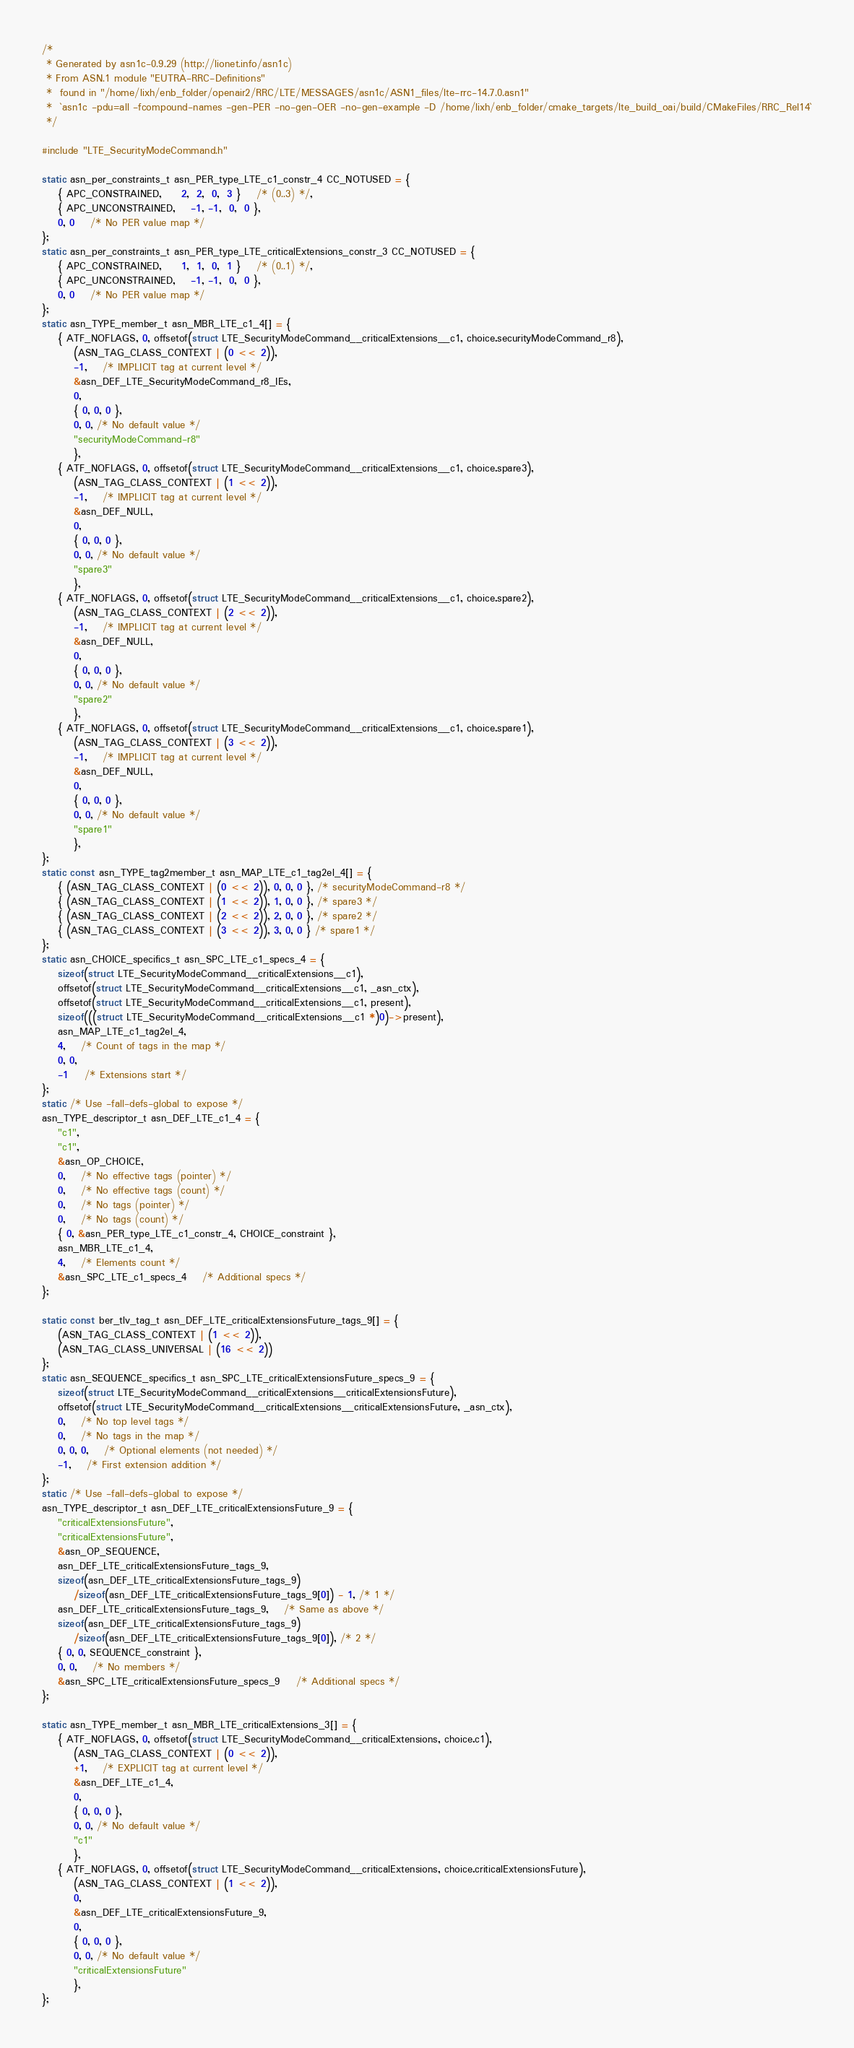<code> <loc_0><loc_0><loc_500><loc_500><_C_>/*
 * Generated by asn1c-0.9.29 (http://lionet.info/asn1c)
 * From ASN.1 module "EUTRA-RRC-Definitions"
 * 	found in "/home/lixh/enb_folder/openair2/RRC/LTE/MESSAGES/asn1c/ASN1_files/lte-rrc-14.7.0.asn1"
 * 	`asn1c -pdu=all -fcompound-names -gen-PER -no-gen-OER -no-gen-example -D /home/lixh/enb_folder/cmake_targets/lte_build_oai/build/CMakeFiles/RRC_Rel14`
 */

#include "LTE_SecurityModeCommand.h"

static asn_per_constraints_t asn_PER_type_LTE_c1_constr_4 CC_NOTUSED = {
	{ APC_CONSTRAINED,	 2,  2,  0,  3 }	/* (0..3) */,
	{ APC_UNCONSTRAINED,	-1, -1,  0,  0 },
	0, 0	/* No PER value map */
};
static asn_per_constraints_t asn_PER_type_LTE_criticalExtensions_constr_3 CC_NOTUSED = {
	{ APC_CONSTRAINED,	 1,  1,  0,  1 }	/* (0..1) */,
	{ APC_UNCONSTRAINED,	-1, -1,  0,  0 },
	0, 0	/* No PER value map */
};
static asn_TYPE_member_t asn_MBR_LTE_c1_4[] = {
	{ ATF_NOFLAGS, 0, offsetof(struct LTE_SecurityModeCommand__criticalExtensions__c1, choice.securityModeCommand_r8),
		(ASN_TAG_CLASS_CONTEXT | (0 << 2)),
		-1,	/* IMPLICIT tag at current level */
		&asn_DEF_LTE_SecurityModeCommand_r8_IEs,
		0,
		{ 0, 0, 0 },
		0, 0, /* No default value */
		"securityModeCommand-r8"
		},
	{ ATF_NOFLAGS, 0, offsetof(struct LTE_SecurityModeCommand__criticalExtensions__c1, choice.spare3),
		(ASN_TAG_CLASS_CONTEXT | (1 << 2)),
		-1,	/* IMPLICIT tag at current level */
		&asn_DEF_NULL,
		0,
		{ 0, 0, 0 },
		0, 0, /* No default value */
		"spare3"
		},
	{ ATF_NOFLAGS, 0, offsetof(struct LTE_SecurityModeCommand__criticalExtensions__c1, choice.spare2),
		(ASN_TAG_CLASS_CONTEXT | (2 << 2)),
		-1,	/* IMPLICIT tag at current level */
		&asn_DEF_NULL,
		0,
		{ 0, 0, 0 },
		0, 0, /* No default value */
		"spare2"
		},
	{ ATF_NOFLAGS, 0, offsetof(struct LTE_SecurityModeCommand__criticalExtensions__c1, choice.spare1),
		(ASN_TAG_CLASS_CONTEXT | (3 << 2)),
		-1,	/* IMPLICIT tag at current level */
		&asn_DEF_NULL,
		0,
		{ 0, 0, 0 },
		0, 0, /* No default value */
		"spare1"
		},
};
static const asn_TYPE_tag2member_t asn_MAP_LTE_c1_tag2el_4[] = {
    { (ASN_TAG_CLASS_CONTEXT | (0 << 2)), 0, 0, 0 }, /* securityModeCommand-r8 */
    { (ASN_TAG_CLASS_CONTEXT | (1 << 2)), 1, 0, 0 }, /* spare3 */
    { (ASN_TAG_CLASS_CONTEXT | (2 << 2)), 2, 0, 0 }, /* spare2 */
    { (ASN_TAG_CLASS_CONTEXT | (3 << 2)), 3, 0, 0 } /* spare1 */
};
static asn_CHOICE_specifics_t asn_SPC_LTE_c1_specs_4 = {
	sizeof(struct LTE_SecurityModeCommand__criticalExtensions__c1),
	offsetof(struct LTE_SecurityModeCommand__criticalExtensions__c1, _asn_ctx),
	offsetof(struct LTE_SecurityModeCommand__criticalExtensions__c1, present),
	sizeof(((struct LTE_SecurityModeCommand__criticalExtensions__c1 *)0)->present),
	asn_MAP_LTE_c1_tag2el_4,
	4,	/* Count of tags in the map */
	0, 0,
	-1	/* Extensions start */
};
static /* Use -fall-defs-global to expose */
asn_TYPE_descriptor_t asn_DEF_LTE_c1_4 = {
	"c1",
	"c1",
	&asn_OP_CHOICE,
	0,	/* No effective tags (pointer) */
	0,	/* No effective tags (count) */
	0,	/* No tags (pointer) */
	0,	/* No tags (count) */
	{ 0, &asn_PER_type_LTE_c1_constr_4, CHOICE_constraint },
	asn_MBR_LTE_c1_4,
	4,	/* Elements count */
	&asn_SPC_LTE_c1_specs_4	/* Additional specs */
};

static const ber_tlv_tag_t asn_DEF_LTE_criticalExtensionsFuture_tags_9[] = {
	(ASN_TAG_CLASS_CONTEXT | (1 << 2)),
	(ASN_TAG_CLASS_UNIVERSAL | (16 << 2))
};
static asn_SEQUENCE_specifics_t asn_SPC_LTE_criticalExtensionsFuture_specs_9 = {
	sizeof(struct LTE_SecurityModeCommand__criticalExtensions__criticalExtensionsFuture),
	offsetof(struct LTE_SecurityModeCommand__criticalExtensions__criticalExtensionsFuture, _asn_ctx),
	0,	/* No top level tags */
	0,	/* No tags in the map */
	0, 0, 0,	/* Optional elements (not needed) */
	-1,	/* First extension addition */
};
static /* Use -fall-defs-global to expose */
asn_TYPE_descriptor_t asn_DEF_LTE_criticalExtensionsFuture_9 = {
	"criticalExtensionsFuture",
	"criticalExtensionsFuture",
	&asn_OP_SEQUENCE,
	asn_DEF_LTE_criticalExtensionsFuture_tags_9,
	sizeof(asn_DEF_LTE_criticalExtensionsFuture_tags_9)
		/sizeof(asn_DEF_LTE_criticalExtensionsFuture_tags_9[0]) - 1, /* 1 */
	asn_DEF_LTE_criticalExtensionsFuture_tags_9,	/* Same as above */
	sizeof(asn_DEF_LTE_criticalExtensionsFuture_tags_9)
		/sizeof(asn_DEF_LTE_criticalExtensionsFuture_tags_9[0]), /* 2 */
	{ 0, 0, SEQUENCE_constraint },
	0, 0,	/* No members */
	&asn_SPC_LTE_criticalExtensionsFuture_specs_9	/* Additional specs */
};

static asn_TYPE_member_t asn_MBR_LTE_criticalExtensions_3[] = {
	{ ATF_NOFLAGS, 0, offsetof(struct LTE_SecurityModeCommand__criticalExtensions, choice.c1),
		(ASN_TAG_CLASS_CONTEXT | (0 << 2)),
		+1,	/* EXPLICIT tag at current level */
		&asn_DEF_LTE_c1_4,
		0,
		{ 0, 0, 0 },
		0, 0, /* No default value */
		"c1"
		},
	{ ATF_NOFLAGS, 0, offsetof(struct LTE_SecurityModeCommand__criticalExtensions, choice.criticalExtensionsFuture),
		(ASN_TAG_CLASS_CONTEXT | (1 << 2)),
		0,
		&asn_DEF_LTE_criticalExtensionsFuture_9,
		0,
		{ 0, 0, 0 },
		0, 0, /* No default value */
		"criticalExtensionsFuture"
		},
};</code> 